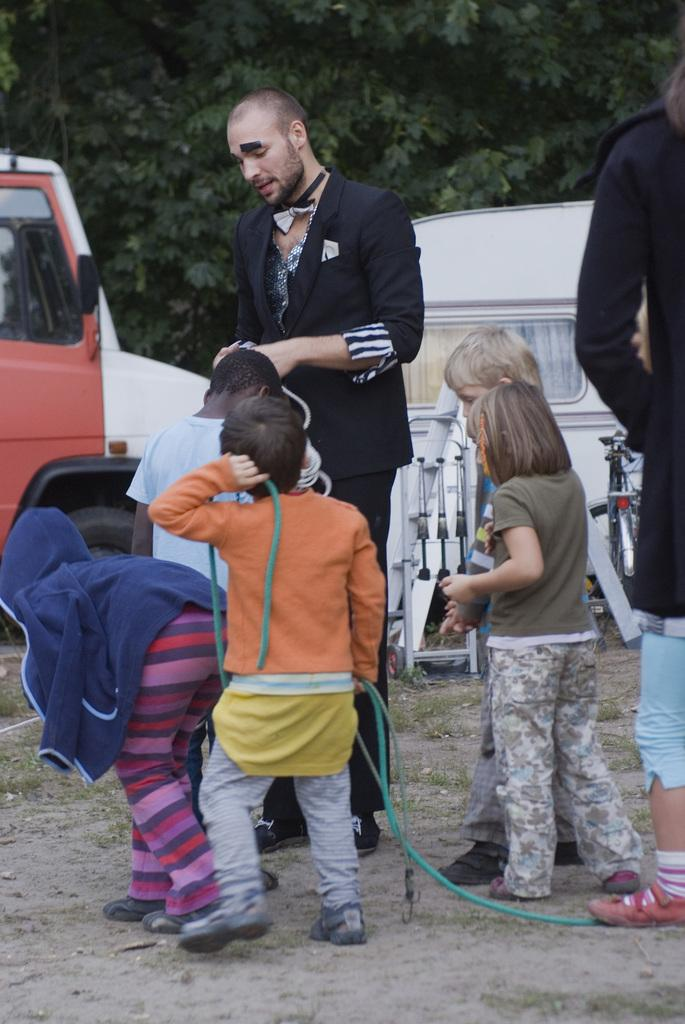Who is present in the image? There are children and persons in the image. What can be seen in the background of the image? There are trees visible in the image. What else is present in the image besides people? There are vehicles in the image. What type of button can be seen on the jellyfish in the image? There is no jellyfish or button present in the image. How does the toothpaste affect the children in the image? There is no toothpaste present in the image, so its effect on the children cannot be determined. 